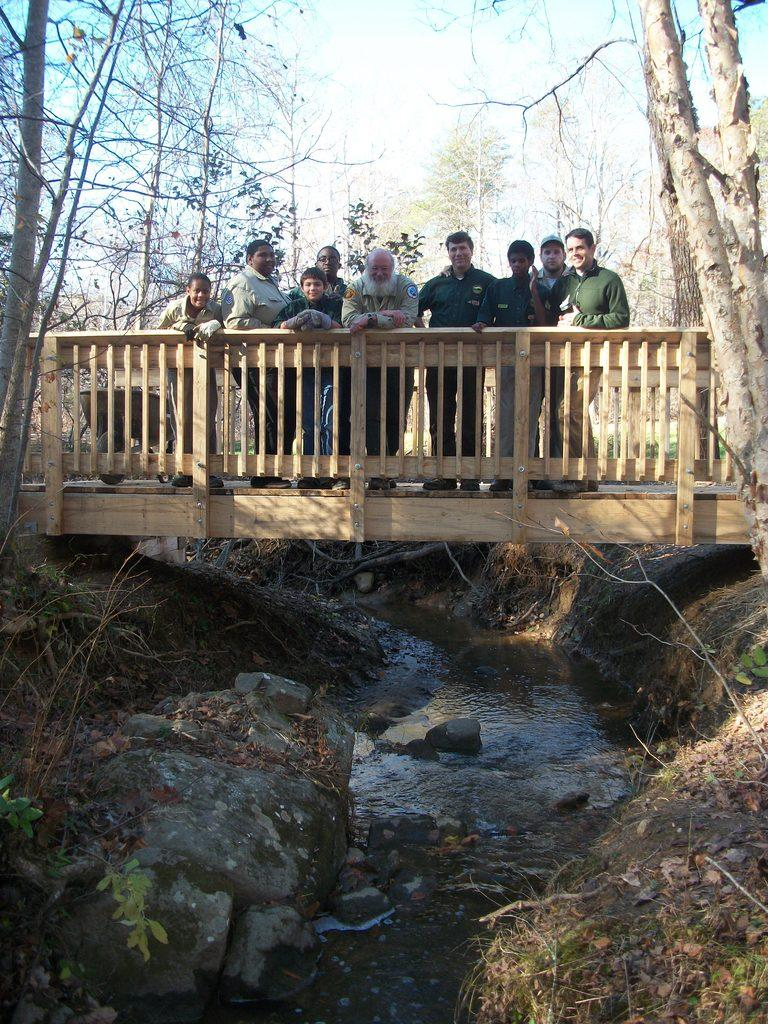What are the people in the image standing on? The people in the image are standing on a wooden bridge. What can be seen at the bottom of the image? Water, stones, and plants are visible at the bottom of the image. What is visible in the background of the image? Trees and the sky are visible in the background of the image. How do the people in the image express their feelings of regret? There is no indication of feelings or regret in the image; it only shows people standing on a wooden bridge. Can you see any chickens in the image? No, there are no chickens present in the image. 